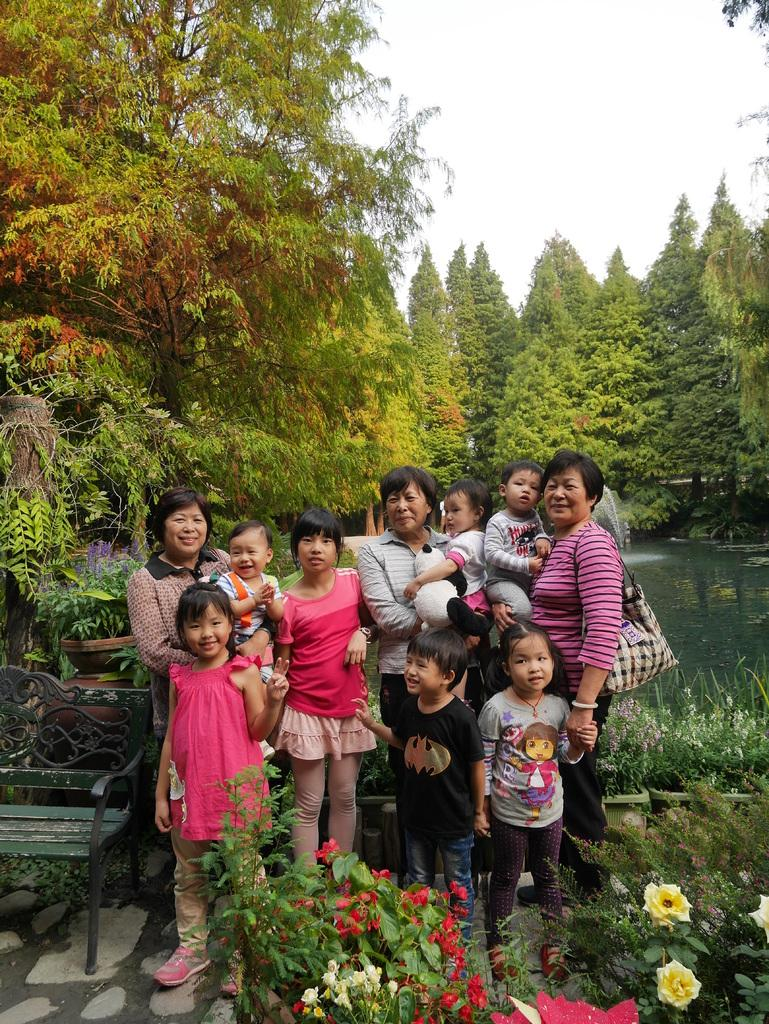What are the people in the image doing? The people in the image are standing on the ground. What can be seen around the plants in the image? There are flowers around the plants in the image. What piece of furniture is present in the image? There is a bench in the image. What body of water is visible in the image? There is a lake in the image. What type of vegetation is present in the image? There are trees in the image. Can you tell me how many bears are sitting on the bench in the image? There are no bears present in the image; it features people standing on the ground, plants, flowers, a bench, a lake, and trees. What type of sheet is covering the lake in the image? There is no sheet covering the lake in the image; the lake is visible as it is. 